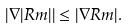<formula> <loc_0><loc_0><loc_500><loc_500>{ \left | \nabla | R m | \right | \leq | \nabla R m | . }</formula> 